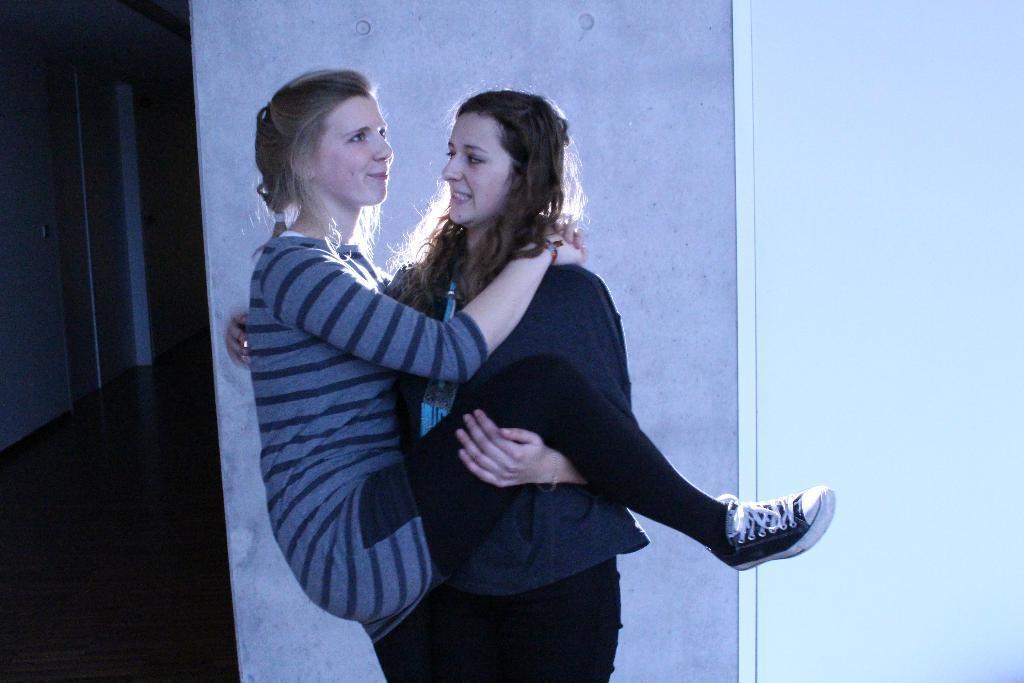How would you summarize this image in a sentence or two? In the background there are a few walls. At the left bottom of the image there is a floor. In the middle of the image there are two women. 